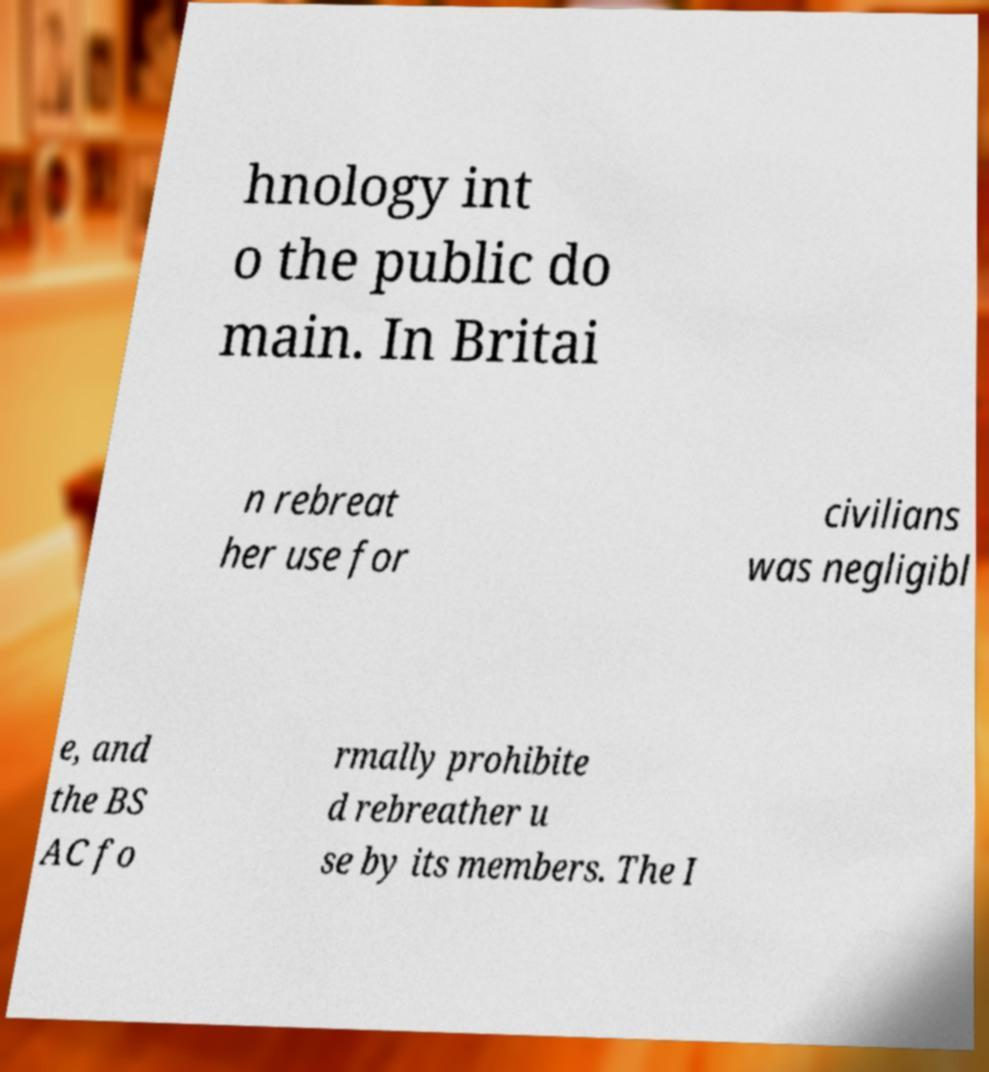What messages or text are displayed in this image? I need them in a readable, typed format. hnology int o the public do main. In Britai n rebreat her use for civilians was negligibl e, and the BS AC fo rmally prohibite d rebreather u se by its members. The I 